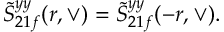<formula> <loc_0><loc_0><loc_500><loc_500>\tilde { S } _ { 2 1 f } ^ { y y } ( r , \vee ) = \tilde { S } _ { 2 1 f } ^ { y y } ( - r , \vee ) .</formula> 